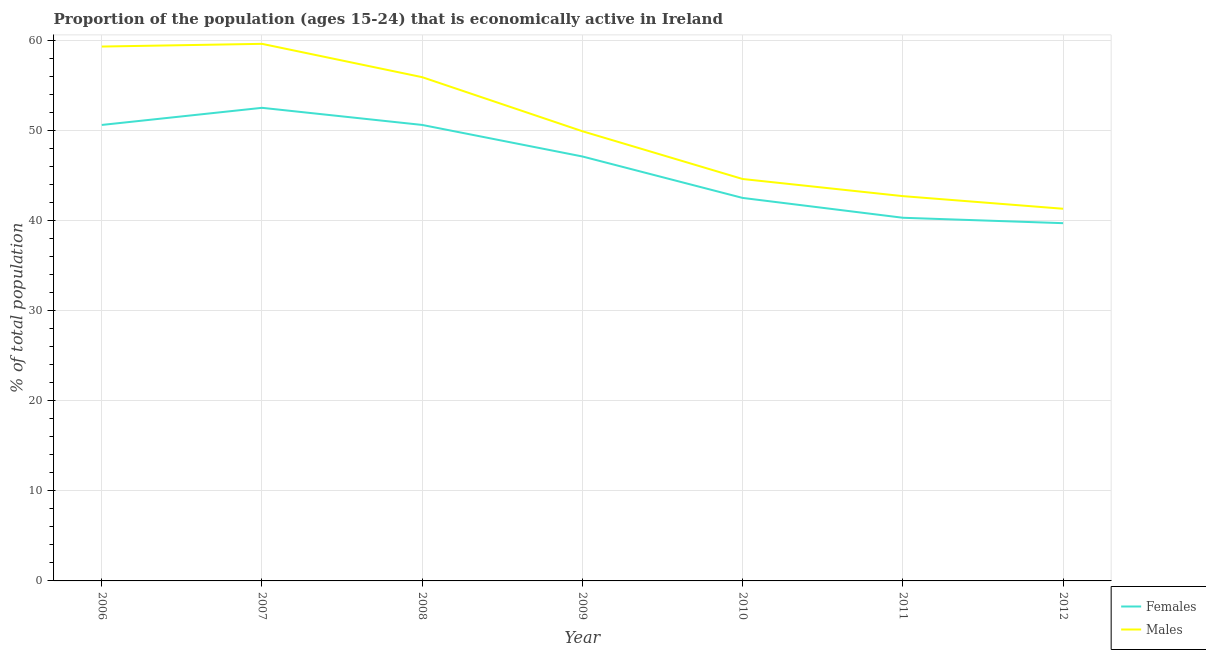Is the number of lines equal to the number of legend labels?
Make the answer very short. Yes. What is the percentage of economically active female population in 2010?
Provide a succinct answer. 42.5. Across all years, what is the maximum percentage of economically active male population?
Your answer should be compact. 59.6. Across all years, what is the minimum percentage of economically active female population?
Your answer should be compact. 39.7. In which year was the percentage of economically active female population minimum?
Offer a terse response. 2012. What is the total percentage of economically active male population in the graph?
Offer a terse response. 353.3. What is the difference between the percentage of economically active male population in 2008 and that in 2009?
Give a very brief answer. 6. What is the difference between the percentage of economically active female population in 2009 and the percentage of economically active male population in 2012?
Provide a short and direct response. 5.8. What is the average percentage of economically active male population per year?
Your answer should be compact. 50.47. In the year 2010, what is the difference between the percentage of economically active male population and percentage of economically active female population?
Keep it short and to the point. 2.1. In how many years, is the percentage of economically active male population greater than 30 %?
Offer a very short reply. 7. What is the ratio of the percentage of economically active male population in 2009 to that in 2012?
Offer a terse response. 1.21. Is the percentage of economically active male population in 2011 less than that in 2012?
Offer a terse response. No. What is the difference between the highest and the second highest percentage of economically active female population?
Offer a terse response. 1.9. What is the difference between the highest and the lowest percentage of economically active female population?
Provide a short and direct response. 12.8. In how many years, is the percentage of economically active female population greater than the average percentage of economically active female population taken over all years?
Offer a very short reply. 4. Is the percentage of economically active female population strictly greater than the percentage of economically active male population over the years?
Offer a terse response. No. Is the percentage of economically active female population strictly less than the percentage of economically active male population over the years?
Provide a short and direct response. Yes. How many lines are there?
Offer a very short reply. 2. Where does the legend appear in the graph?
Your answer should be very brief. Bottom right. How are the legend labels stacked?
Keep it short and to the point. Vertical. What is the title of the graph?
Provide a succinct answer. Proportion of the population (ages 15-24) that is economically active in Ireland. What is the label or title of the X-axis?
Your response must be concise. Year. What is the label or title of the Y-axis?
Provide a short and direct response. % of total population. What is the % of total population of Females in 2006?
Your answer should be very brief. 50.6. What is the % of total population of Males in 2006?
Make the answer very short. 59.3. What is the % of total population of Females in 2007?
Make the answer very short. 52.5. What is the % of total population of Males in 2007?
Your response must be concise. 59.6. What is the % of total population of Females in 2008?
Provide a succinct answer. 50.6. What is the % of total population of Males in 2008?
Keep it short and to the point. 55.9. What is the % of total population of Females in 2009?
Offer a terse response. 47.1. What is the % of total population in Males in 2009?
Provide a short and direct response. 49.9. What is the % of total population in Females in 2010?
Ensure brevity in your answer.  42.5. What is the % of total population of Males in 2010?
Your answer should be compact. 44.6. What is the % of total population in Females in 2011?
Provide a succinct answer. 40.3. What is the % of total population in Males in 2011?
Provide a short and direct response. 42.7. What is the % of total population of Females in 2012?
Offer a terse response. 39.7. What is the % of total population of Males in 2012?
Offer a very short reply. 41.3. Across all years, what is the maximum % of total population of Females?
Your answer should be very brief. 52.5. Across all years, what is the maximum % of total population in Males?
Give a very brief answer. 59.6. Across all years, what is the minimum % of total population in Females?
Give a very brief answer. 39.7. Across all years, what is the minimum % of total population of Males?
Make the answer very short. 41.3. What is the total % of total population in Females in the graph?
Offer a terse response. 323.3. What is the total % of total population of Males in the graph?
Provide a short and direct response. 353.3. What is the difference between the % of total population in Females in 2006 and that in 2007?
Make the answer very short. -1.9. What is the difference between the % of total population of Females in 2006 and that in 2008?
Your answer should be very brief. 0. What is the difference between the % of total population in Females in 2006 and that in 2009?
Ensure brevity in your answer.  3.5. What is the difference between the % of total population of Females in 2006 and that in 2010?
Ensure brevity in your answer.  8.1. What is the difference between the % of total population in Females in 2006 and that in 2011?
Your answer should be compact. 10.3. What is the difference between the % of total population in Males in 2006 and that in 2011?
Your answer should be very brief. 16.6. What is the difference between the % of total population in Females in 2007 and that in 2008?
Provide a succinct answer. 1.9. What is the difference between the % of total population of Males in 2007 and that in 2008?
Ensure brevity in your answer.  3.7. What is the difference between the % of total population of Females in 2007 and that in 2009?
Your answer should be compact. 5.4. What is the difference between the % of total population in Males in 2007 and that in 2010?
Ensure brevity in your answer.  15. What is the difference between the % of total population in Males in 2008 and that in 2009?
Offer a very short reply. 6. What is the difference between the % of total population in Females in 2008 and that in 2010?
Your response must be concise. 8.1. What is the difference between the % of total population in Females in 2008 and that in 2011?
Provide a short and direct response. 10.3. What is the difference between the % of total population of Females in 2008 and that in 2012?
Give a very brief answer. 10.9. What is the difference between the % of total population in Males in 2008 and that in 2012?
Make the answer very short. 14.6. What is the difference between the % of total population in Females in 2009 and that in 2010?
Your answer should be compact. 4.6. What is the difference between the % of total population of Males in 2009 and that in 2010?
Make the answer very short. 5.3. What is the difference between the % of total population of Females in 2009 and that in 2012?
Provide a short and direct response. 7.4. What is the difference between the % of total population in Females in 2010 and that in 2011?
Your response must be concise. 2.2. What is the difference between the % of total population in Females in 2006 and the % of total population in Males in 2009?
Your answer should be compact. 0.7. What is the difference between the % of total population of Females in 2006 and the % of total population of Males in 2010?
Make the answer very short. 6. What is the difference between the % of total population of Females in 2006 and the % of total population of Males in 2012?
Offer a terse response. 9.3. What is the difference between the % of total population in Females in 2007 and the % of total population in Males in 2008?
Offer a very short reply. -3.4. What is the difference between the % of total population of Females in 2007 and the % of total population of Males in 2010?
Make the answer very short. 7.9. What is the difference between the % of total population in Females in 2007 and the % of total population in Males in 2011?
Offer a terse response. 9.8. What is the difference between the % of total population in Females in 2008 and the % of total population in Males in 2009?
Give a very brief answer. 0.7. What is the difference between the % of total population of Females in 2008 and the % of total population of Males in 2011?
Provide a succinct answer. 7.9. What is the difference between the % of total population of Females in 2008 and the % of total population of Males in 2012?
Keep it short and to the point. 9.3. What is the difference between the % of total population of Females in 2009 and the % of total population of Males in 2010?
Provide a short and direct response. 2.5. What is the difference between the % of total population of Females in 2009 and the % of total population of Males in 2011?
Offer a terse response. 4.4. What is the difference between the % of total population of Females in 2009 and the % of total population of Males in 2012?
Provide a short and direct response. 5.8. What is the difference between the % of total population in Females in 2010 and the % of total population in Males in 2012?
Your response must be concise. 1.2. What is the average % of total population in Females per year?
Offer a terse response. 46.19. What is the average % of total population in Males per year?
Ensure brevity in your answer.  50.47. In the year 2006, what is the difference between the % of total population of Females and % of total population of Males?
Provide a succinct answer. -8.7. In the year 2008, what is the difference between the % of total population of Females and % of total population of Males?
Your response must be concise. -5.3. In the year 2010, what is the difference between the % of total population in Females and % of total population in Males?
Give a very brief answer. -2.1. In the year 2012, what is the difference between the % of total population in Females and % of total population in Males?
Your answer should be compact. -1.6. What is the ratio of the % of total population of Females in 2006 to that in 2007?
Ensure brevity in your answer.  0.96. What is the ratio of the % of total population in Males in 2006 to that in 2007?
Your answer should be very brief. 0.99. What is the ratio of the % of total population in Females in 2006 to that in 2008?
Your answer should be very brief. 1. What is the ratio of the % of total population of Males in 2006 to that in 2008?
Offer a very short reply. 1.06. What is the ratio of the % of total population in Females in 2006 to that in 2009?
Your response must be concise. 1.07. What is the ratio of the % of total population of Males in 2006 to that in 2009?
Offer a terse response. 1.19. What is the ratio of the % of total population of Females in 2006 to that in 2010?
Ensure brevity in your answer.  1.19. What is the ratio of the % of total population in Males in 2006 to that in 2010?
Provide a short and direct response. 1.33. What is the ratio of the % of total population in Females in 2006 to that in 2011?
Provide a short and direct response. 1.26. What is the ratio of the % of total population in Males in 2006 to that in 2011?
Your answer should be very brief. 1.39. What is the ratio of the % of total population in Females in 2006 to that in 2012?
Give a very brief answer. 1.27. What is the ratio of the % of total population in Males in 2006 to that in 2012?
Provide a succinct answer. 1.44. What is the ratio of the % of total population of Females in 2007 to that in 2008?
Make the answer very short. 1.04. What is the ratio of the % of total population in Males in 2007 to that in 2008?
Your answer should be compact. 1.07. What is the ratio of the % of total population of Females in 2007 to that in 2009?
Your answer should be very brief. 1.11. What is the ratio of the % of total population of Males in 2007 to that in 2009?
Provide a succinct answer. 1.19. What is the ratio of the % of total population of Females in 2007 to that in 2010?
Offer a very short reply. 1.24. What is the ratio of the % of total population in Males in 2007 to that in 2010?
Keep it short and to the point. 1.34. What is the ratio of the % of total population in Females in 2007 to that in 2011?
Make the answer very short. 1.3. What is the ratio of the % of total population in Males in 2007 to that in 2011?
Give a very brief answer. 1.4. What is the ratio of the % of total population in Females in 2007 to that in 2012?
Provide a succinct answer. 1.32. What is the ratio of the % of total population in Males in 2007 to that in 2012?
Make the answer very short. 1.44. What is the ratio of the % of total population of Females in 2008 to that in 2009?
Offer a terse response. 1.07. What is the ratio of the % of total population in Males in 2008 to that in 2009?
Offer a very short reply. 1.12. What is the ratio of the % of total population of Females in 2008 to that in 2010?
Offer a very short reply. 1.19. What is the ratio of the % of total population of Males in 2008 to that in 2010?
Provide a succinct answer. 1.25. What is the ratio of the % of total population in Females in 2008 to that in 2011?
Offer a terse response. 1.26. What is the ratio of the % of total population in Males in 2008 to that in 2011?
Your response must be concise. 1.31. What is the ratio of the % of total population in Females in 2008 to that in 2012?
Your answer should be compact. 1.27. What is the ratio of the % of total population in Males in 2008 to that in 2012?
Make the answer very short. 1.35. What is the ratio of the % of total population in Females in 2009 to that in 2010?
Offer a terse response. 1.11. What is the ratio of the % of total population in Males in 2009 to that in 2010?
Provide a short and direct response. 1.12. What is the ratio of the % of total population of Females in 2009 to that in 2011?
Offer a very short reply. 1.17. What is the ratio of the % of total population of Males in 2009 to that in 2011?
Ensure brevity in your answer.  1.17. What is the ratio of the % of total population in Females in 2009 to that in 2012?
Provide a short and direct response. 1.19. What is the ratio of the % of total population of Males in 2009 to that in 2012?
Make the answer very short. 1.21. What is the ratio of the % of total population in Females in 2010 to that in 2011?
Keep it short and to the point. 1.05. What is the ratio of the % of total population of Males in 2010 to that in 2011?
Provide a short and direct response. 1.04. What is the ratio of the % of total population of Females in 2010 to that in 2012?
Provide a short and direct response. 1.07. What is the ratio of the % of total population in Males in 2010 to that in 2012?
Make the answer very short. 1.08. What is the ratio of the % of total population in Females in 2011 to that in 2012?
Ensure brevity in your answer.  1.02. What is the ratio of the % of total population in Males in 2011 to that in 2012?
Make the answer very short. 1.03. What is the difference between the highest and the second highest % of total population of Females?
Keep it short and to the point. 1.9. What is the difference between the highest and the lowest % of total population in Females?
Keep it short and to the point. 12.8. What is the difference between the highest and the lowest % of total population of Males?
Provide a succinct answer. 18.3. 